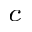<formula> <loc_0><loc_0><loc_500><loc_500>_ { c }</formula> 